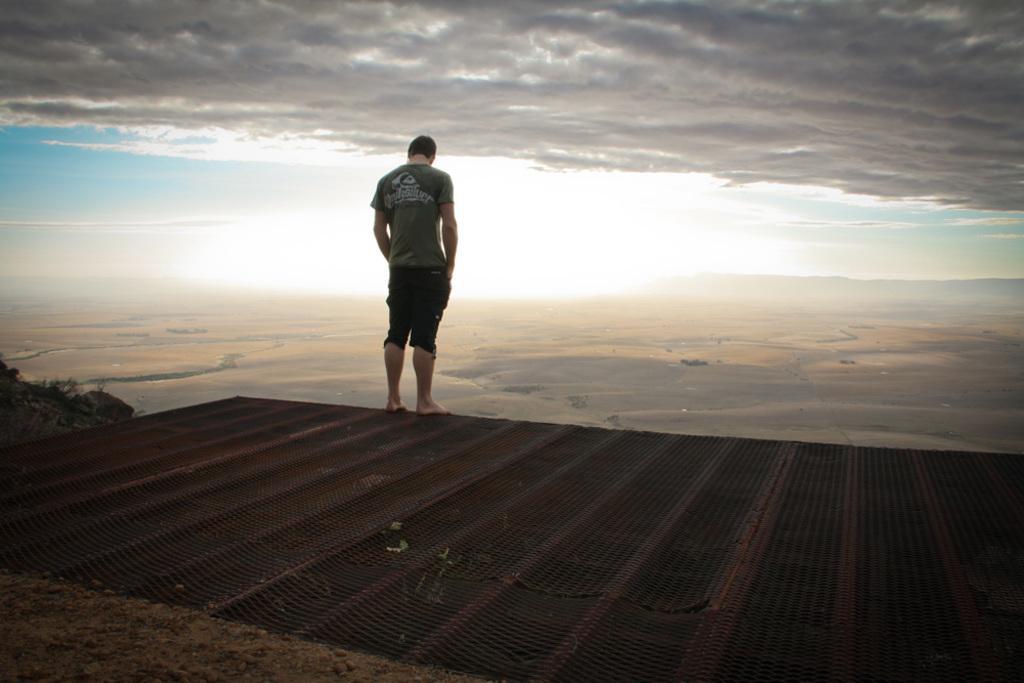Can you describe this image briefly? In this image there is a man standing on the metal grill. At the top there is the sky. At the bottom there is sand. On the left side there are small plants. 